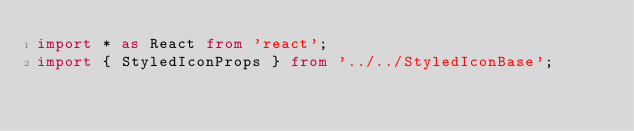<code> <loc_0><loc_0><loc_500><loc_500><_TypeScript_>import * as React from 'react';
import { StyledIconProps } from '../../StyledIconBase';</code> 